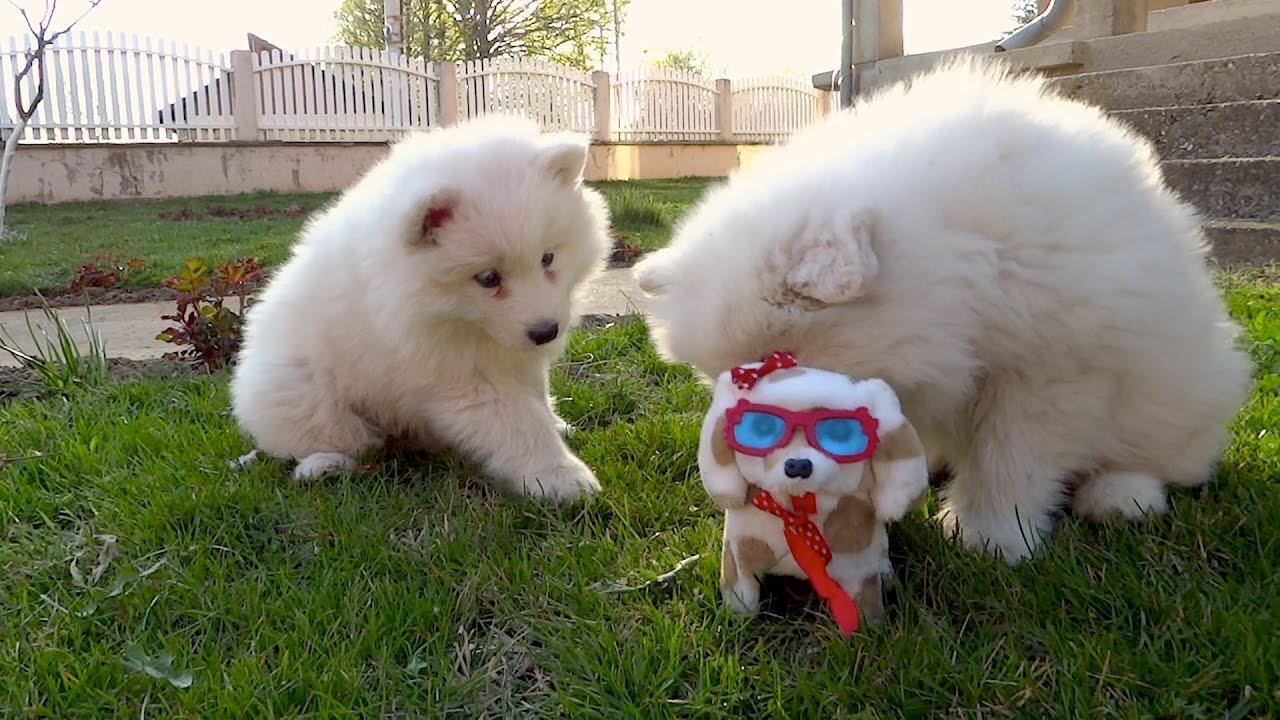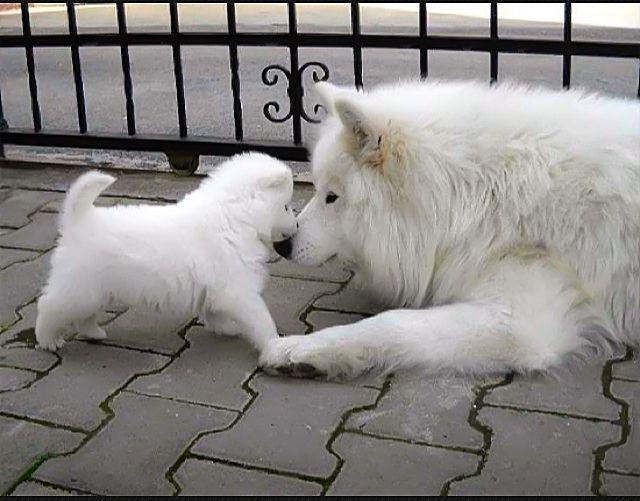The first image is the image on the left, the second image is the image on the right. For the images shown, is this caption "There are exactly three dogs in total." true? Answer yes or no. No. The first image is the image on the left, the second image is the image on the right. For the images shown, is this caption "Two white dogs are playing with a toy." true? Answer yes or no. Yes. 